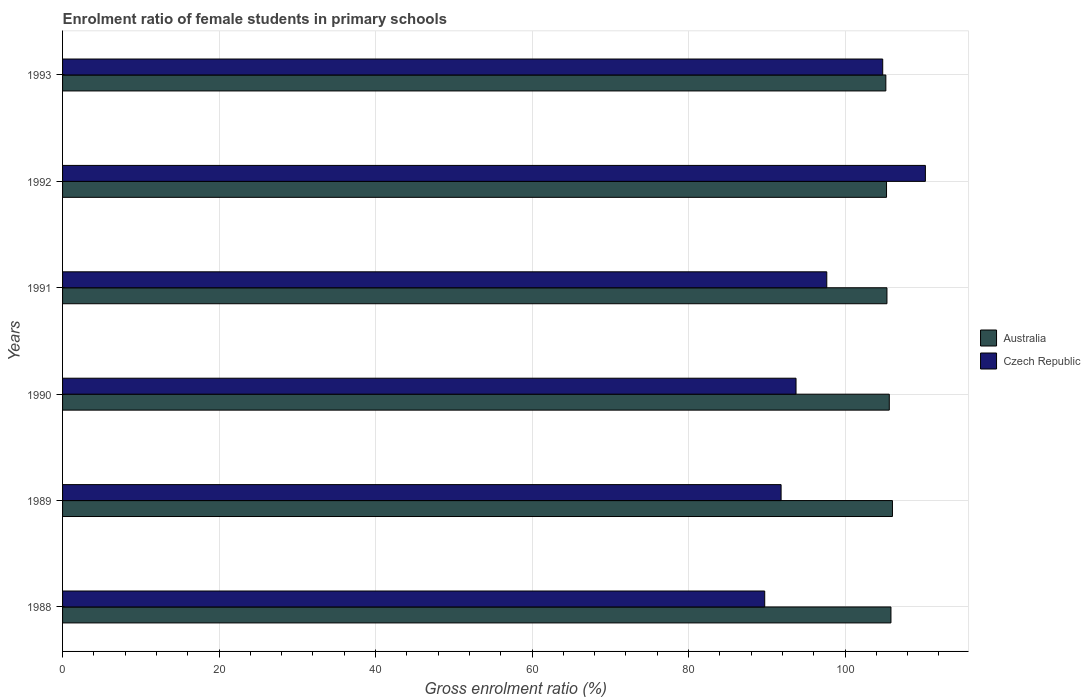How many different coloured bars are there?
Give a very brief answer. 2. Are the number of bars per tick equal to the number of legend labels?
Give a very brief answer. Yes. Are the number of bars on each tick of the Y-axis equal?
Provide a succinct answer. Yes. What is the enrolment ratio of female students in primary schools in Australia in 1991?
Keep it short and to the point. 105.36. Across all years, what is the maximum enrolment ratio of female students in primary schools in Australia?
Offer a terse response. 106.06. Across all years, what is the minimum enrolment ratio of female students in primary schools in Australia?
Offer a terse response. 105.22. In which year was the enrolment ratio of female students in primary schools in Czech Republic minimum?
Your answer should be compact. 1988. What is the total enrolment ratio of female students in primary schools in Czech Republic in the graph?
Offer a very short reply. 588.06. What is the difference between the enrolment ratio of female students in primary schools in Czech Republic in 1988 and that in 1993?
Your answer should be very brief. -15.08. What is the difference between the enrolment ratio of female students in primary schools in Czech Republic in 1992 and the enrolment ratio of female students in primary schools in Australia in 1989?
Provide a succinct answer. 4.21. What is the average enrolment ratio of female students in primary schools in Australia per year?
Your answer should be compact. 105.58. In the year 1991, what is the difference between the enrolment ratio of female students in primary schools in Australia and enrolment ratio of female students in primary schools in Czech Republic?
Make the answer very short. 7.69. What is the ratio of the enrolment ratio of female students in primary schools in Australia in 1988 to that in 1989?
Ensure brevity in your answer.  1. Is the enrolment ratio of female students in primary schools in Australia in 1989 less than that in 1991?
Your answer should be very brief. No. What is the difference between the highest and the second highest enrolment ratio of female students in primary schools in Czech Republic?
Provide a short and direct response. 5.45. What is the difference between the highest and the lowest enrolment ratio of female students in primary schools in Czech Republic?
Give a very brief answer. 20.53. Is the sum of the enrolment ratio of female students in primary schools in Australia in 1988 and 1993 greater than the maximum enrolment ratio of female students in primary schools in Czech Republic across all years?
Give a very brief answer. Yes. What does the 2nd bar from the bottom in 1991 represents?
Provide a succinct answer. Czech Republic. Are all the bars in the graph horizontal?
Give a very brief answer. Yes. What is the difference between two consecutive major ticks on the X-axis?
Give a very brief answer. 20. Are the values on the major ticks of X-axis written in scientific E-notation?
Your response must be concise. No. Does the graph contain any zero values?
Ensure brevity in your answer.  No. How many legend labels are there?
Your answer should be compact. 2. How are the legend labels stacked?
Offer a terse response. Vertical. What is the title of the graph?
Give a very brief answer. Enrolment ratio of female students in primary schools. What is the label or title of the X-axis?
Your answer should be very brief. Gross enrolment ratio (%). What is the label or title of the Y-axis?
Offer a very short reply. Years. What is the Gross enrolment ratio (%) of Australia in 1988?
Ensure brevity in your answer.  105.87. What is the Gross enrolment ratio (%) in Czech Republic in 1988?
Offer a very short reply. 89.74. What is the Gross enrolment ratio (%) in Australia in 1989?
Provide a short and direct response. 106.06. What is the Gross enrolment ratio (%) in Czech Republic in 1989?
Provide a short and direct response. 91.83. What is the Gross enrolment ratio (%) of Australia in 1990?
Make the answer very short. 105.66. What is the Gross enrolment ratio (%) in Czech Republic in 1990?
Provide a short and direct response. 93.74. What is the Gross enrolment ratio (%) in Australia in 1991?
Offer a very short reply. 105.36. What is the Gross enrolment ratio (%) in Czech Republic in 1991?
Ensure brevity in your answer.  97.67. What is the Gross enrolment ratio (%) in Australia in 1992?
Your answer should be compact. 105.3. What is the Gross enrolment ratio (%) of Czech Republic in 1992?
Give a very brief answer. 110.27. What is the Gross enrolment ratio (%) in Australia in 1993?
Your answer should be compact. 105.22. What is the Gross enrolment ratio (%) of Czech Republic in 1993?
Offer a terse response. 104.82. Across all years, what is the maximum Gross enrolment ratio (%) of Australia?
Offer a terse response. 106.06. Across all years, what is the maximum Gross enrolment ratio (%) in Czech Republic?
Your answer should be compact. 110.27. Across all years, what is the minimum Gross enrolment ratio (%) in Australia?
Give a very brief answer. 105.22. Across all years, what is the minimum Gross enrolment ratio (%) of Czech Republic?
Provide a short and direct response. 89.74. What is the total Gross enrolment ratio (%) in Australia in the graph?
Provide a succinct answer. 633.46. What is the total Gross enrolment ratio (%) of Czech Republic in the graph?
Ensure brevity in your answer.  588.06. What is the difference between the Gross enrolment ratio (%) of Australia in 1988 and that in 1989?
Offer a very short reply. -0.19. What is the difference between the Gross enrolment ratio (%) of Czech Republic in 1988 and that in 1989?
Your answer should be compact. -2.09. What is the difference between the Gross enrolment ratio (%) in Australia in 1988 and that in 1990?
Offer a very short reply. 0.21. What is the difference between the Gross enrolment ratio (%) in Czech Republic in 1988 and that in 1990?
Give a very brief answer. -4. What is the difference between the Gross enrolment ratio (%) in Australia in 1988 and that in 1991?
Your response must be concise. 0.51. What is the difference between the Gross enrolment ratio (%) in Czech Republic in 1988 and that in 1991?
Ensure brevity in your answer.  -7.93. What is the difference between the Gross enrolment ratio (%) of Australia in 1988 and that in 1992?
Offer a very short reply. 0.57. What is the difference between the Gross enrolment ratio (%) in Czech Republic in 1988 and that in 1992?
Your answer should be compact. -20.53. What is the difference between the Gross enrolment ratio (%) in Australia in 1988 and that in 1993?
Your answer should be very brief. 0.65. What is the difference between the Gross enrolment ratio (%) in Czech Republic in 1988 and that in 1993?
Give a very brief answer. -15.08. What is the difference between the Gross enrolment ratio (%) in Australia in 1989 and that in 1990?
Provide a short and direct response. 0.4. What is the difference between the Gross enrolment ratio (%) in Czech Republic in 1989 and that in 1990?
Offer a terse response. -1.91. What is the difference between the Gross enrolment ratio (%) in Australia in 1989 and that in 1991?
Keep it short and to the point. 0.7. What is the difference between the Gross enrolment ratio (%) of Czech Republic in 1989 and that in 1991?
Make the answer very short. -5.84. What is the difference between the Gross enrolment ratio (%) of Australia in 1989 and that in 1992?
Ensure brevity in your answer.  0.76. What is the difference between the Gross enrolment ratio (%) in Czech Republic in 1989 and that in 1992?
Offer a very short reply. -18.44. What is the difference between the Gross enrolment ratio (%) of Australia in 1989 and that in 1993?
Keep it short and to the point. 0.84. What is the difference between the Gross enrolment ratio (%) of Czech Republic in 1989 and that in 1993?
Provide a succinct answer. -12.99. What is the difference between the Gross enrolment ratio (%) of Australia in 1990 and that in 1991?
Ensure brevity in your answer.  0.3. What is the difference between the Gross enrolment ratio (%) of Czech Republic in 1990 and that in 1991?
Keep it short and to the point. -3.93. What is the difference between the Gross enrolment ratio (%) in Australia in 1990 and that in 1992?
Make the answer very short. 0.35. What is the difference between the Gross enrolment ratio (%) in Czech Republic in 1990 and that in 1992?
Offer a very short reply. -16.53. What is the difference between the Gross enrolment ratio (%) in Australia in 1990 and that in 1993?
Provide a short and direct response. 0.44. What is the difference between the Gross enrolment ratio (%) in Czech Republic in 1990 and that in 1993?
Your answer should be compact. -11.08. What is the difference between the Gross enrolment ratio (%) of Australia in 1991 and that in 1992?
Your response must be concise. 0.06. What is the difference between the Gross enrolment ratio (%) in Czech Republic in 1991 and that in 1992?
Provide a succinct answer. -12.6. What is the difference between the Gross enrolment ratio (%) of Australia in 1991 and that in 1993?
Make the answer very short. 0.14. What is the difference between the Gross enrolment ratio (%) in Czech Republic in 1991 and that in 1993?
Offer a very short reply. -7.15. What is the difference between the Gross enrolment ratio (%) of Australia in 1992 and that in 1993?
Your answer should be very brief. 0.09. What is the difference between the Gross enrolment ratio (%) of Czech Republic in 1992 and that in 1993?
Keep it short and to the point. 5.45. What is the difference between the Gross enrolment ratio (%) in Australia in 1988 and the Gross enrolment ratio (%) in Czech Republic in 1989?
Your response must be concise. 14.04. What is the difference between the Gross enrolment ratio (%) of Australia in 1988 and the Gross enrolment ratio (%) of Czech Republic in 1990?
Provide a succinct answer. 12.13. What is the difference between the Gross enrolment ratio (%) of Australia in 1988 and the Gross enrolment ratio (%) of Czech Republic in 1991?
Your answer should be compact. 8.2. What is the difference between the Gross enrolment ratio (%) in Australia in 1988 and the Gross enrolment ratio (%) in Czech Republic in 1992?
Keep it short and to the point. -4.4. What is the difference between the Gross enrolment ratio (%) of Australia in 1988 and the Gross enrolment ratio (%) of Czech Republic in 1993?
Give a very brief answer. 1.05. What is the difference between the Gross enrolment ratio (%) of Australia in 1989 and the Gross enrolment ratio (%) of Czech Republic in 1990?
Your response must be concise. 12.32. What is the difference between the Gross enrolment ratio (%) of Australia in 1989 and the Gross enrolment ratio (%) of Czech Republic in 1991?
Provide a succinct answer. 8.39. What is the difference between the Gross enrolment ratio (%) in Australia in 1989 and the Gross enrolment ratio (%) in Czech Republic in 1992?
Provide a short and direct response. -4.21. What is the difference between the Gross enrolment ratio (%) in Australia in 1989 and the Gross enrolment ratio (%) in Czech Republic in 1993?
Offer a terse response. 1.24. What is the difference between the Gross enrolment ratio (%) in Australia in 1990 and the Gross enrolment ratio (%) in Czech Republic in 1991?
Provide a short and direct response. 7.99. What is the difference between the Gross enrolment ratio (%) of Australia in 1990 and the Gross enrolment ratio (%) of Czech Republic in 1992?
Make the answer very short. -4.61. What is the difference between the Gross enrolment ratio (%) in Australia in 1990 and the Gross enrolment ratio (%) in Czech Republic in 1993?
Ensure brevity in your answer.  0.84. What is the difference between the Gross enrolment ratio (%) in Australia in 1991 and the Gross enrolment ratio (%) in Czech Republic in 1992?
Your answer should be compact. -4.91. What is the difference between the Gross enrolment ratio (%) of Australia in 1991 and the Gross enrolment ratio (%) of Czech Republic in 1993?
Ensure brevity in your answer.  0.54. What is the difference between the Gross enrolment ratio (%) of Australia in 1992 and the Gross enrolment ratio (%) of Czech Republic in 1993?
Your response must be concise. 0.49. What is the average Gross enrolment ratio (%) in Australia per year?
Ensure brevity in your answer.  105.58. What is the average Gross enrolment ratio (%) of Czech Republic per year?
Keep it short and to the point. 98.01. In the year 1988, what is the difference between the Gross enrolment ratio (%) in Australia and Gross enrolment ratio (%) in Czech Republic?
Keep it short and to the point. 16.13. In the year 1989, what is the difference between the Gross enrolment ratio (%) in Australia and Gross enrolment ratio (%) in Czech Republic?
Your answer should be compact. 14.23. In the year 1990, what is the difference between the Gross enrolment ratio (%) in Australia and Gross enrolment ratio (%) in Czech Republic?
Offer a very short reply. 11.92. In the year 1991, what is the difference between the Gross enrolment ratio (%) in Australia and Gross enrolment ratio (%) in Czech Republic?
Offer a very short reply. 7.69. In the year 1992, what is the difference between the Gross enrolment ratio (%) of Australia and Gross enrolment ratio (%) of Czech Republic?
Your answer should be very brief. -4.97. In the year 1993, what is the difference between the Gross enrolment ratio (%) of Australia and Gross enrolment ratio (%) of Czech Republic?
Your response must be concise. 0.4. What is the ratio of the Gross enrolment ratio (%) of Australia in 1988 to that in 1989?
Provide a short and direct response. 1. What is the ratio of the Gross enrolment ratio (%) of Czech Republic in 1988 to that in 1989?
Keep it short and to the point. 0.98. What is the ratio of the Gross enrolment ratio (%) in Australia in 1988 to that in 1990?
Give a very brief answer. 1. What is the ratio of the Gross enrolment ratio (%) in Czech Republic in 1988 to that in 1990?
Give a very brief answer. 0.96. What is the ratio of the Gross enrolment ratio (%) in Czech Republic in 1988 to that in 1991?
Your answer should be compact. 0.92. What is the ratio of the Gross enrolment ratio (%) of Australia in 1988 to that in 1992?
Provide a short and direct response. 1.01. What is the ratio of the Gross enrolment ratio (%) of Czech Republic in 1988 to that in 1992?
Keep it short and to the point. 0.81. What is the ratio of the Gross enrolment ratio (%) in Australia in 1988 to that in 1993?
Offer a very short reply. 1.01. What is the ratio of the Gross enrolment ratio (%) in Czech Republic in 1988 to that in 1993?
Your answer should be very brief. 0.86. What is the ratio of the Gross enrolment ratio (%) of Australia in 1989 to that in 1990?
Keep it short and to the point. 1. What is the ratio of the Gross enrolment ratio (%) of Czech Republic in 1989 to that in 1990?
Your answer should be very brief. 0.98. What is the ratio of the Gross enrolment ratio (%) in Australia in 1989 to that in 1991?
Provide a succinct answer. 1.01. What is the ratio of the Gross enrolment ratio (%) in Czech Republic in 1989 to that in 1991?
Ensure brevity in your answer.  0.94. What is the ratio of the Gross enrolment ratio (%) of Czech Republic in 1989 to that in 1992?
Your answer should be compact. 0.83. What is the ratio of the Gross enrolment ratio (%) in Australia in 1989 to that in 1993?
Provide a succinct answer. 1.01. What is the ratio of the Gross enrolment ratio (%) in Czech Republic in 1989 to that in 1993?
Your answer should be very brief. 0.88. What is the ratio of the Gross enrolment ratio (%) of Czech Republic in 1990 to that in 1991?
Your response must be concise. 0.96. What is the ratio of the Gross enrolment ratio (%) of Czech Republic in 1990 to that in 1992?
Keep it short and to the point. 0.85. What is the ratio of the Gross enrolment ratio (%) in Czech Republic in 1990 to that in 1993?
Your answer should be compact. 0.89. What is the ratio of the Gross enrolment ratio (%) of Czech Republic in 1991 to that in 1992?
Ensure brevity in your answer.  0.89. What is the ratio of the Gross enrolment ratio (%) of Czech Republic in 1991 to that in 1993?
Make the answer very short. 0.93. What is the ratio of the Gross enrolment ratio (%) in Czech Republic in 1992 to that in 1993?
Offer a very short reply. 1.05. What is the difference between the highest and the second highest Gross enrolment ratio (%) in Australia?
Provide a short and direct response. 0.19. What is the difference between the highest and the second highest Gross enrolment ratio (%) of Czech Republic?
Provide a short and direct response. 5.45. What is the difference between the highest and the lowest Gross enrolment ratio (%) in Australia?
Give a very brief answer. 0.84. What is the difference between the highest and the lowest Gross enrolment ratio (%) in Czech Republic?
Your response must be concise. 20.53. 